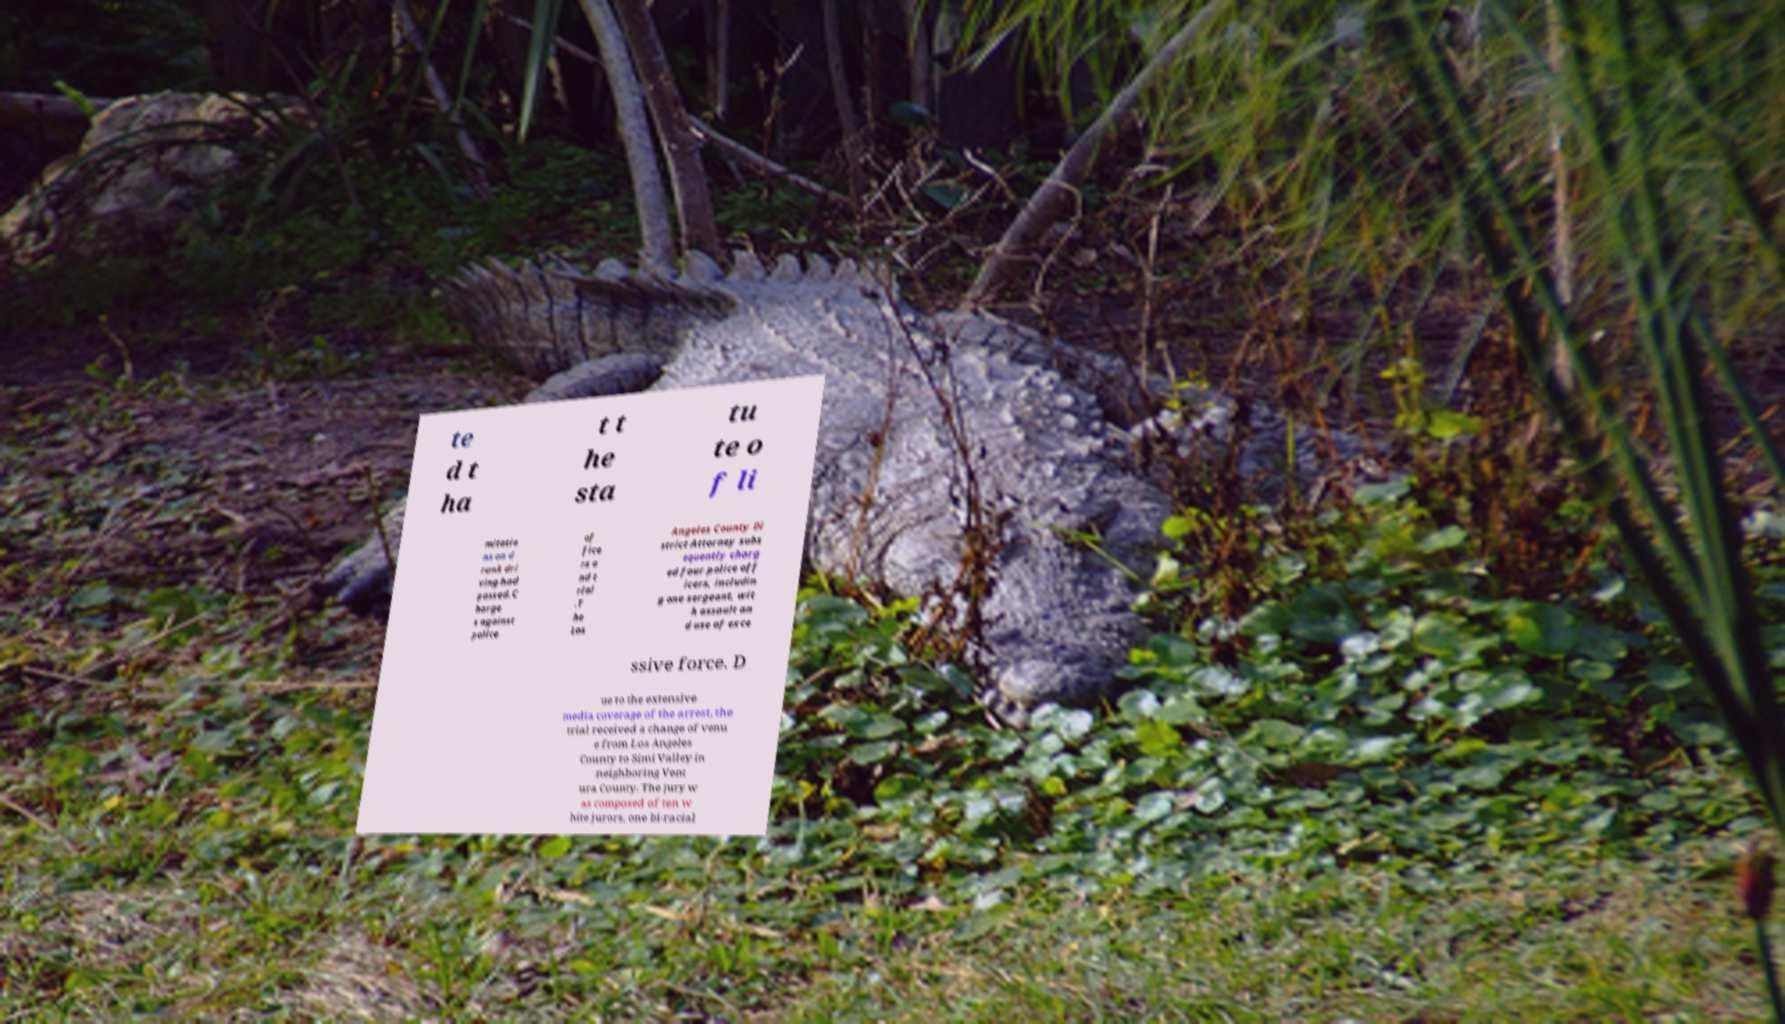For documentation purposes, I need the text within this image transcribed. Could you provide that? te d t ha t t he sta tu te o f li mitatio ns on d runk dri ving had passed.C harge s against police of fice rs a nd t rial .T he Los Angeles County Di strict Attorney subs equently charg ed four police off icers, includin g one sergeant, wit h assault an d use of exce ssive force. D ue to the extensive media coverage of the arrest, the trial received a change of venu e from Los Angeles County to Simi Valley in neighboring Vent ura County. The jury w as composed of ten w hite jurors, one bi-racial 